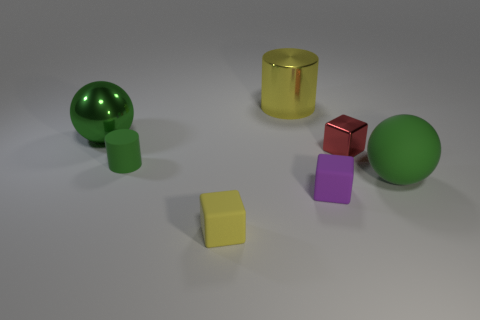Add 1 metal blocks. How many objects exist? 8 Subtract all yellow cubes. How many cubes are left? 2 Subtract 1 cubes. How many cubes are left? 2 Subtract all cyan blocks. Subtract all gray cylinders. How many blocks are left? 3 Subtract all spheres. How many objects are left? 5 Subtract all yellow shiny objects. Subtract all yellow matte cubes. How many objects are left? 5 Add 2 small green matte things. How many small green matte things are left? 3 Add 6 tiny matte things. How many tiny matte things exist? 9 Subtract 0 brown cubes. How many objects are left? 7 